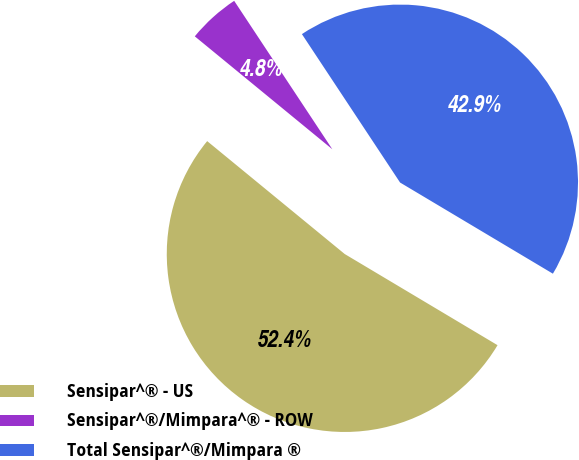Convert chart to OTSL. <chart><loc_0><loc_0><loc_500><loc_500><pie_chart><fcel>Sensipar^® - US<fcel>Sensipar^®/Mimpara^® - ROW<fcel>Total Sensipar^®/Mimpara ®<nl><fcel>52.38%<fcel>4.76%<fcel>42.86%<nl></chart> 